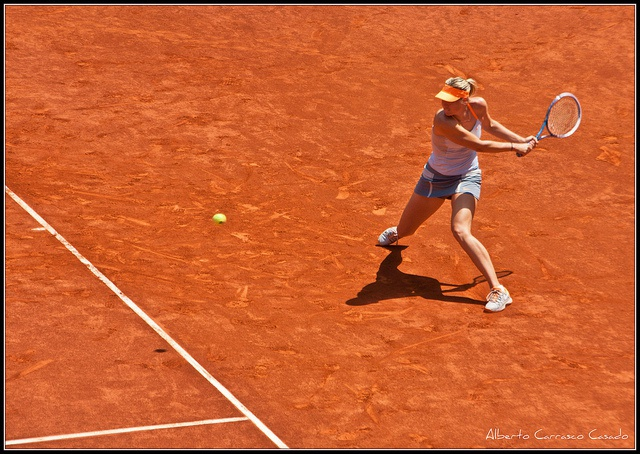Describe the objects in this image and their specific colors. I can see people in black, maroon, and brown tones, tennis racket in black, salmon, red, and lightgray tones, and sports ball in black, khaki, and olive tones in this image. 